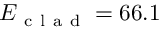Convert formula to latex. <formula><loc_0><loc_0><loc_500><loc_500>E _ { c l a d } = 6 6 . 1</formula> 